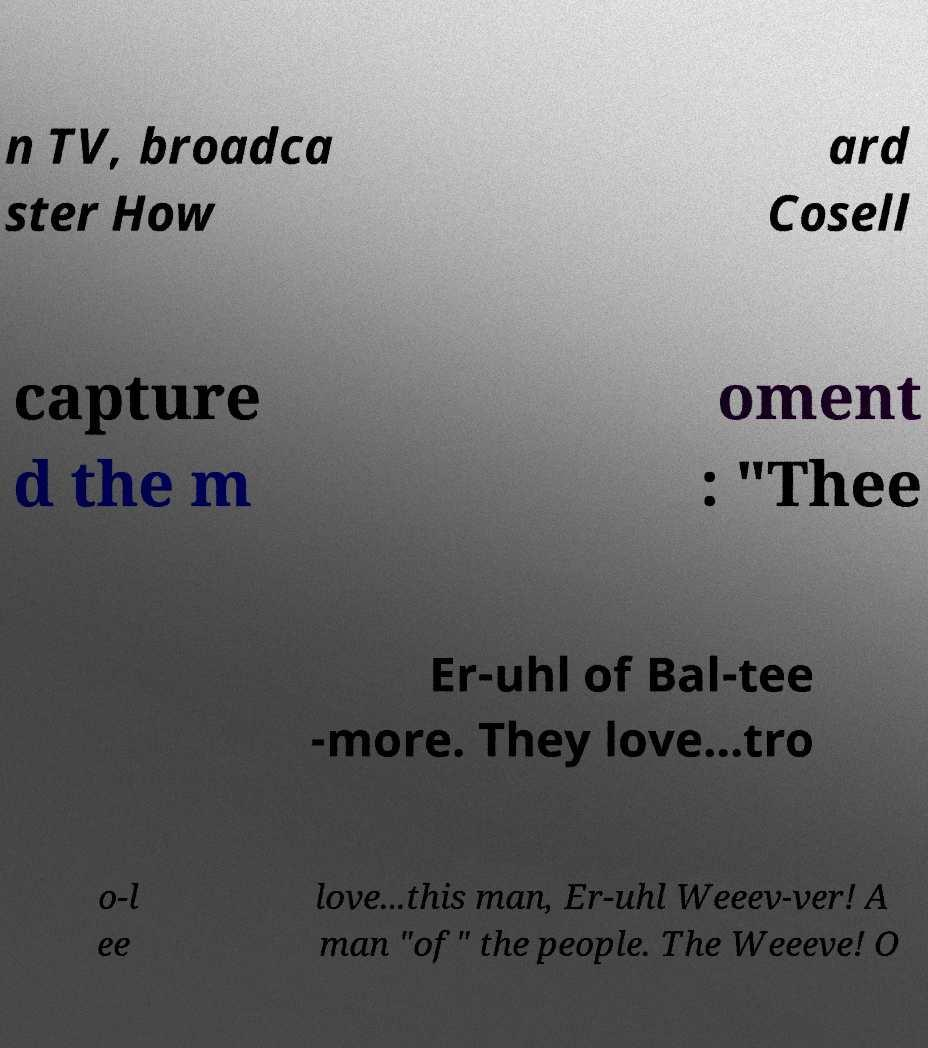Please identify and transcribe the text found in this image. n TV, broadca ster How ard Cosell capture d the m oment : "Thee Er-uhl of Bal-tee -more. They love...tro o-l ee love...this man, Er-uhl Weeev-ver! A man "of" the people. The Weeeve! O 